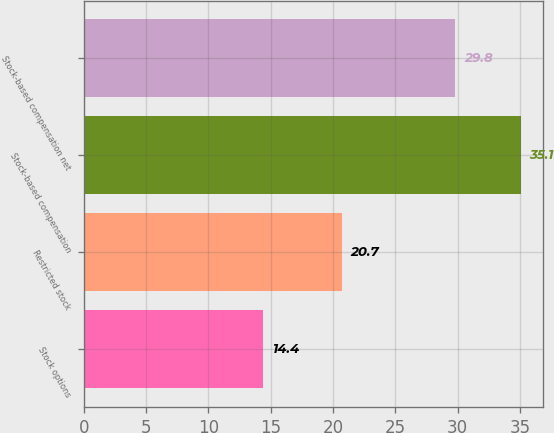<chart> <loc_0><loc_0><loc_500><loc_500><bar_chart><fcel>Stock options<fcel>Restricted stock<fcel>Stock-based compensation<fcel>Stock-based compensation net<nl><fcel>14.4<fcel>20.7<fcel>35.1<fcel>29.8<nl></chart> 